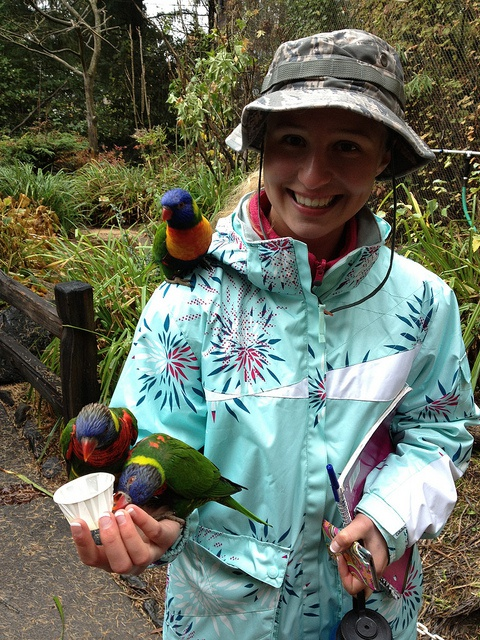Describe the objects in this image and their specific colors. I can see people in black, lightblue, teal, and white tones, bird in black, maroon, and darkgreen tones, bird in black, maroon, darkgreen, and gray tones, book in black, maroon, gray, and purple tones, and cup in black, white, tan, and darkgray tones in this image. 